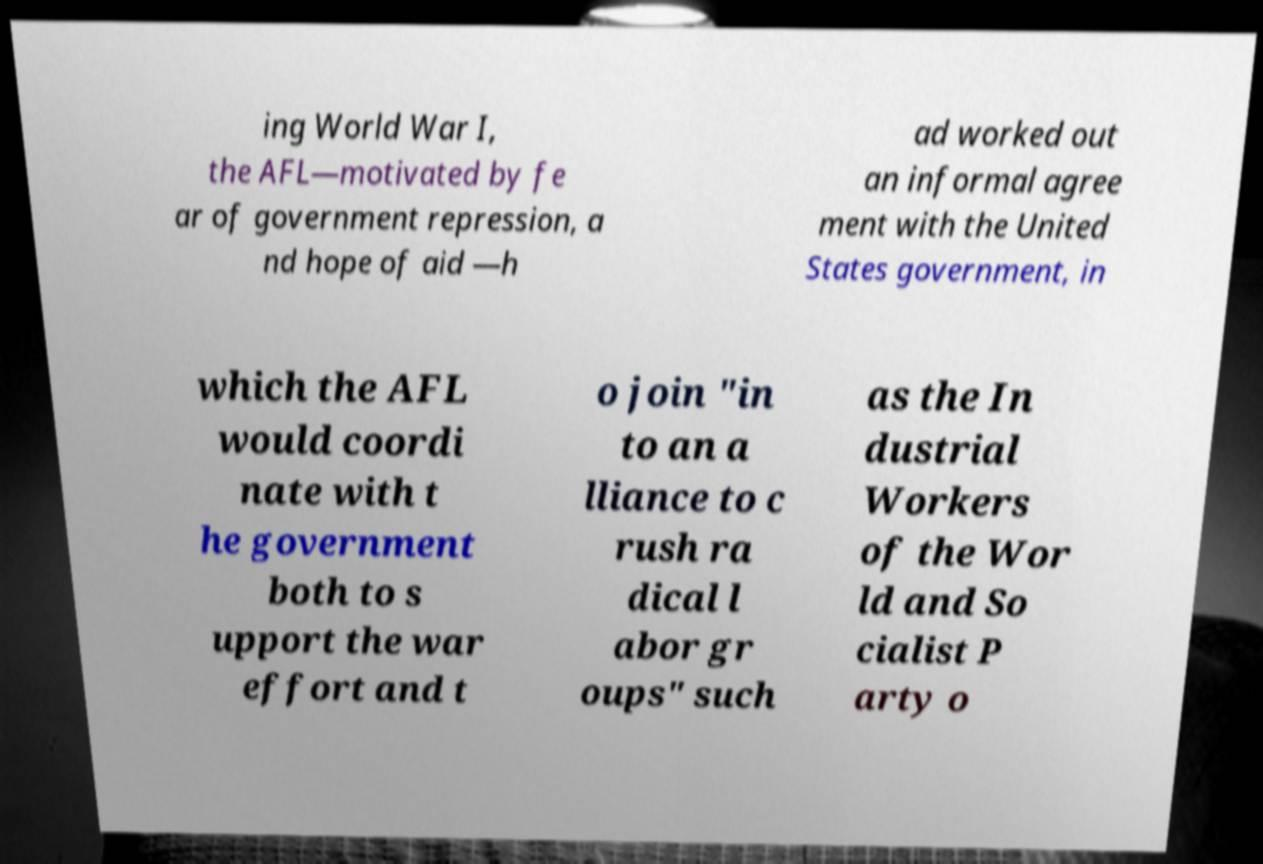What messages or text are displayed in this image? I need them in a readable, typed format. ing World War I, the AFL—motivated by fe ar of government repression, a nd hope of aid —h ad worked out an informal agree ment with the United States government, in which the AFL would coordi nate with t he government both to s upport the war effort and t o join "in to an a lliance to c rush ra dical l abor gr oups" such as the In dustrial Workers of the Wor ld and So cialist P arty o 